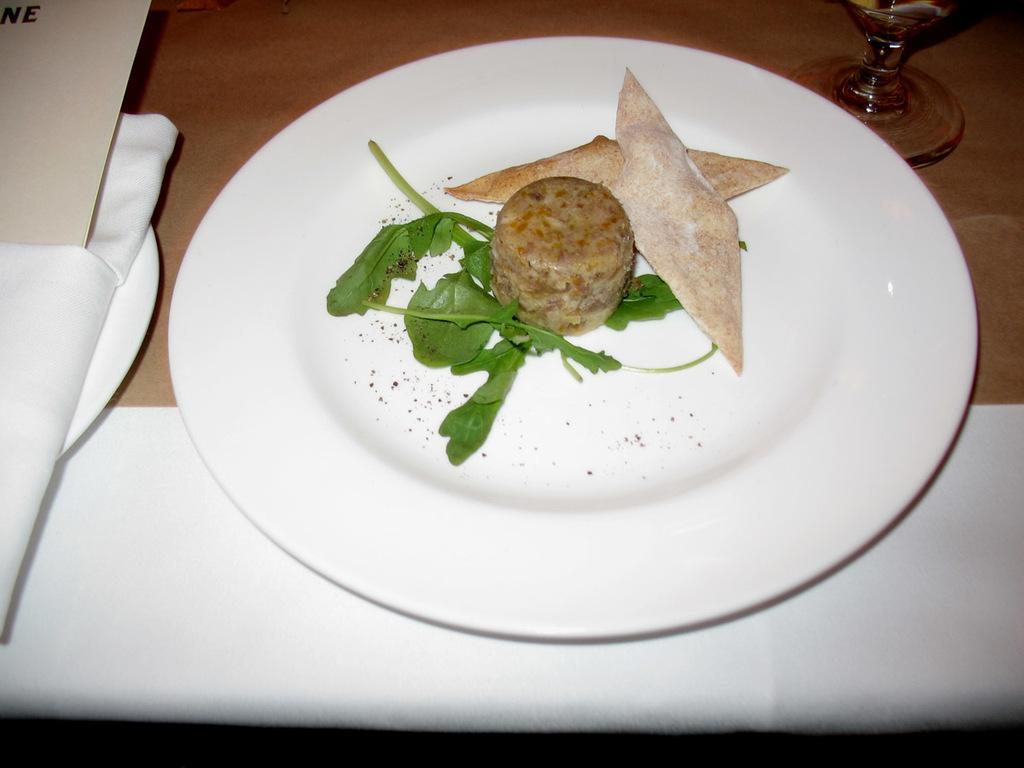What is the main food item visible in the image? There is a food item in a white plate in the image. What can be seen on the left side of the image? A napkin and a card are present on the left side of the image. Where is the glass located in the image? The glass is visible in the right top of the image. What thoughts does the doctor have about the food item in the image? There is no doctor present in the image, so it is not possible to determine their thoughts about the food item. 